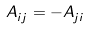Convert formula to latex. <formula><loc_0><loc_0><loc_500><loc_500>A ^ { \ } _ { i j } = - A ^ { \ } _ { j i }</formula> 